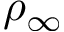Convert formula to latex. <formula><loc_0><loc_0><loc_500><loc_500>\rho _ { \infty }</formula> 